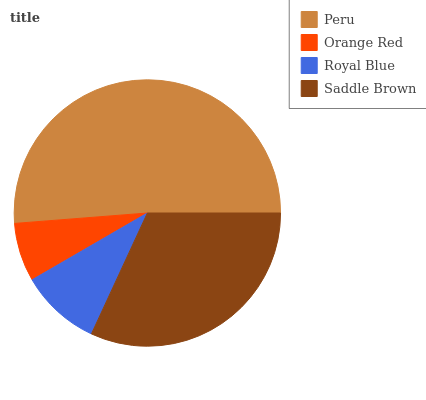Is Orange Red the minimum?
Answer yes or no. Yes. Is Peru the maximum?
Answer yes or no. Yes. Is Royal Blue the minimum?
Answer yes or no. No. Is Royal Blue the maximum?
Answer yes or no. No. Is Royal Blue greater than Orange Red?
Answer yes or no. Yes. Is Orange Red less than Royal Blue?
Answer yes or no. Yes. Is Orange Red greater than Royal Blue?
Answer yes or no. No. Is Royal Blue less than Orange Red?
Answer yes or no. No. Is Saddle Brown the high median?
Answer yes or no. Yes. Is Royal Blue the low median?
Answer yes or no. Yes. Is Peru the high median?
Answer yes or no. No. Is Peru the low median?
Answer yes or no. No. 